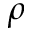<formula> <loc_0><loc_0><loc_500><loc_500>\rho</formula> 